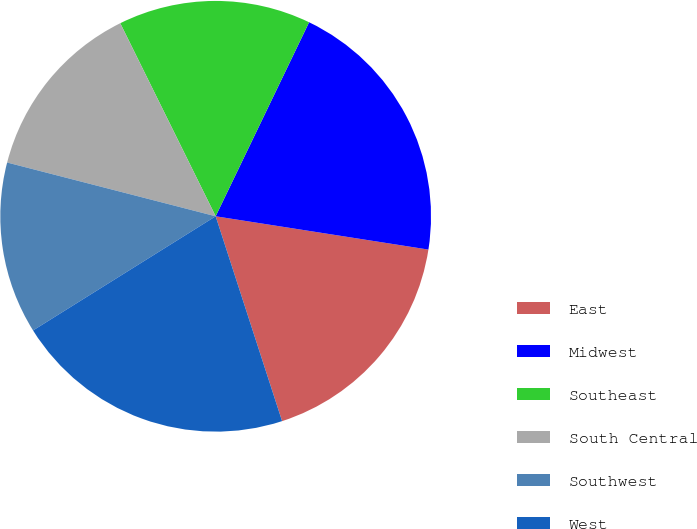Convert chart to OTSL. <chart><loc_0><loc_0><loc_500><loc_500><pie_chart><fcel>East<fcel>Midwest<fcel>Southeast<fcel>South Central<fcel>Southwest<fcel>West<nl><fcel>17.54%<fcel>20.33%<fcel>14.45%<fcel>13.68%<fcel>12.91%<fcel>21.1%<nl></chart> 